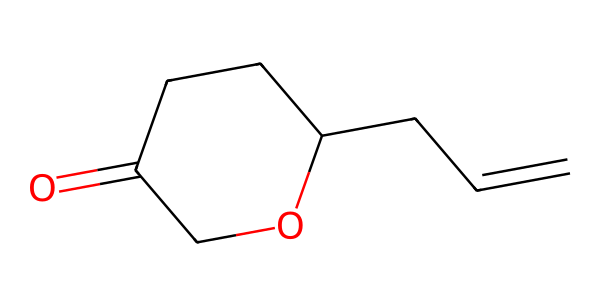how many rings are present in the chemical structure? The provided structure shows a cyclic arrangement at C1 and C2 (the "C" atoms in the SMILES). This indicates there is one ring present in the compound.
Answer: one ring what type of functional group is present in this compound? The SMILES representation shows a carbonyl group (indicated by "O=") adjacent to a cyclic structure, which confirms that this chemical contains a cyclic ester (lactone).
Answer: lactone how many carbon atoms are in this chemical structure? By counting the carbon atoms in the SMILES, we see there are six carbon atoms (noted as "C" organized in the branches and the ring).
Answer: six carbon atoms is this compound aromatic? The presence of a complete conjugated system with alternating double bonds is a requirement for aromaticity; however, this structure does not fulfill that criteria as it is a cyclic ether with no alternating double bonds.
Answer: no what is the molecular formula for this chemical? To determine the molecular formula, count the atoms represented in the SMILES: C6H10O (from six carbons, ten hydrogens, and one oxygen), which gives us the overall formula.
Answer: C6H10O which element has the highest oxidation state in this compound? The highest oxidation state typically occurs in elements bonded to more electronegative elements. In this case, the carbonyl carbon (C=O) is more oxidized than the others, thus having the highest oxidation state.
Answer: carbon what type of aroma is typically associated with compounds like jasmine oil? Jasmine oil, which contains similar structures to the provided SMILES, is often described as sweet and floral.
Answer: sweet and floral 